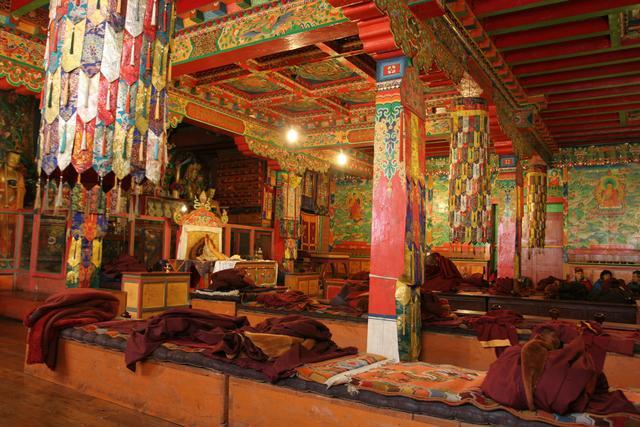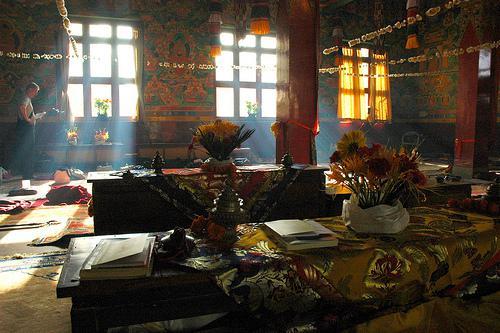The first image is the image on the left, the second image is the image on the right. Assess this claim about the two images: "Both images are of the inside of a room.". Correct or not? Answer yes or no. Yes. The first image is the image on the left, the second image is the image on the right. Considering the images on both sides, is "The left and right image contains the same number of inside monasteries." valid? Answer yes or no. Yes. 